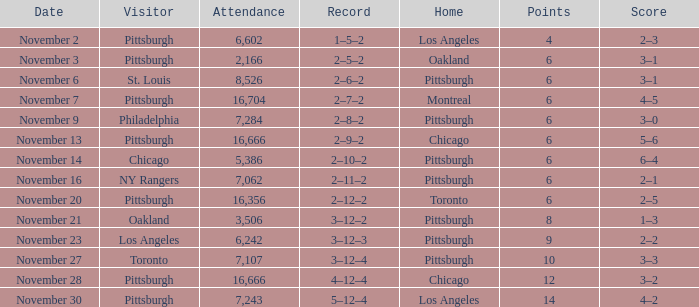What is the sum of the points of the game with philadelphia as the visitor and an attendance greater than 7,284? None. 